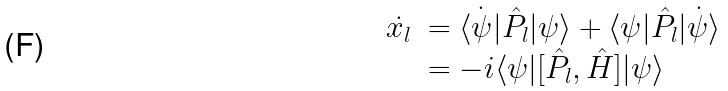Convert formula to latex. <formula><loc_0><loc_0><loc_500><loc_500>\begin{array} { l l } \dot { x _ { l } } & = \dot { \langle \psi | } \hat { P } _ { l } | \psi \rangle + \langle \psi | \hat { P } _ { l } \dot { | \psi \rangle } \\ & = - i \langle \psi | [ \hat { P } _ { l } , \hat { H } ] | \psi \rangle \\ \end{array}</formula> 